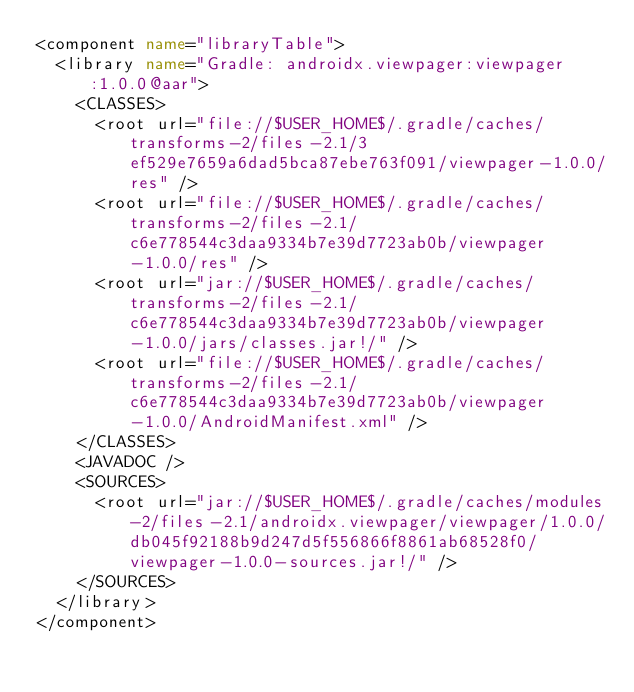Convert code to text. <code><loc_0><loc_0><loc_500><loc_500><_XML_><component name="libraryTable">
  <library name="Gradle: androidx.viewpager:viewpager:1.0.0@aar">
    <CLASSES>
      <root url="file://$USER_HOME$/.gradle/caches/transforms-2/files-2.1/3ef529e7659a6dad5bca87ebe763f091/viewpager-1.0.0/res" />
      <root url="file://$USER_HOME$/.gradle/caches/transforms-2/files-2.1/c6e778544c3daa9334b7e39d7723ab0b/viewpager-1.0.0/res" />
      <root url="jar://$USER_HOME$/.gradle/caches/transforms-2/files-2.1/c6e778544c3daa9334b7e39d7723ab0b/viewpager-1.0.0/jars/classes.jar!/" />
      <root url="file://$USER_HOME$/.gradle/caches/transforms-2/files-2.1/c6e778544c3daa9334b7e39d7723ab0b/viewpager-1.0.0/AndroidManifest.xml" />
    </CLASSES>
    <JAVADOC />
    <SOURCES>
      <root url="jar://$USER_HOME$/.gradle/caches/modules-2/files-2.1/androidx.viewpager/viewpager/1.0.0/db045f92188b9d247d5f556866f8861ab68528f0/viewpager-1.0.0-sources.jar!/" />
    </SOURCES>
  </library>
</component></code> 